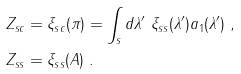<formula> <loc_0><loc_0><loc_500><loc_500>Z _ { s c } & = \xi _ { s c } ( \pi ) = \int _ { s } d \lambda ^ { \prime } \ \xi _ { s s } ( \lambda ^ { \prime } ) a _ { 1 } ( \lambda ^ { \prime } ) \ , \\ Z _ { s s } & = \xi _ { s s } ( A ) \ .</formula> 